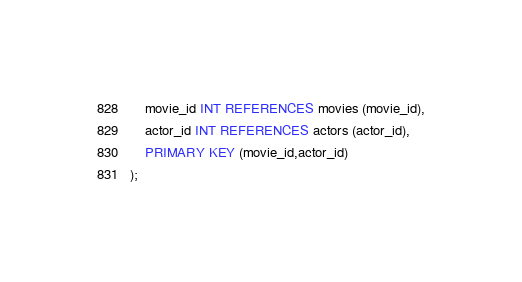<code> <loc_0><loc_0><loc_500><loc_500><_SQL_>	movie_id INT REFERENCES movies (movie_id),
	actor_id INT REFERENCES actors (actor_id),
	PRIMARY KEY (movie_id,actor_id)
);</code> 